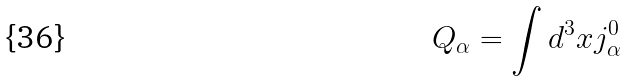<formula> <loc_0><loc_0><loc_500><loc_500>Q _ { \alpha } = \int d ^ { 3 } x j ^ { 0 } _ { \alpha }</formula> 